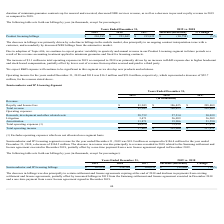According to Xperi Corporation's financial document, What was the primary cause of the decrease in revenue in 2019 compared to 2018? revenue recorded in 2018 related to the Samsung settlement and license agreement executed in December 2018, partially offset by a one-time payment from a new license agreement signed in December 2019. The document states: "n. The decrease in revenue was due principally to revenue recorded in 2018 related to the Samsung settlement and license agreement executed in Decembe..." Also, What was the revenue change between 2018 and 2019? According to the financial document, $104.5 million. The relevant text states: "or the year ended December 31, 2018, a decrease of $104.5 million. The decrease in revenue was due principally to revenue recorded in 2018 related to the Samsung set..." Also, What was the total operating expense in 2017 and 2018, respectively? The document shows two values: 73,519 and 44,074 (in thousands). From the document: "Total operating expenses (1) 44,074 73,519 87,838 Total operating expenses (1) 44,074 73,519 87,838..." Additionally, Which year did the Semiconductor and IP Licensing segment have the highest total operating income? According to the financial document, 2017. The relevant text states: "2019 2018 2017 Increase/(Decrease) % Change..." Also, can you calculate: What is the percentage of research, development, and other related costs as well as litigation expenses over total operating expenses in 2018? To answer this question, I need to perform calculations using the financial data. The calculation is: (27,514+26,099)/73,519 , which equals 72.92 (percentage). This is based on the information: "earch, development and other related costs 28,732 27,514 30,039 Total operating expenses (1) 44,074 73,519 87,838 Litigation 3,471 26,099 36,209..." The key data points involved are: 26,099, 27,514, 73,519. Also, can you calculate: What is the average revenue that the company received in the last three years, i.e. from 2017 to 2019? To answer this question, I need to perform calculations using the financial data. The calculation is: (81,943+186,425+205,809)/3 , which equals 158059 (in thousands). This is based on the information: "Royalty and license fees $ 81,943 $ 186,425 $ 205,809 Royalty and license fees $ 81,943 $ 186,425 $ 205,809 Royalty and license fees $ 81,943 $ 186,425 $ 205,809..." The key data points involved are: 186,425, 205,809, 81,943. 